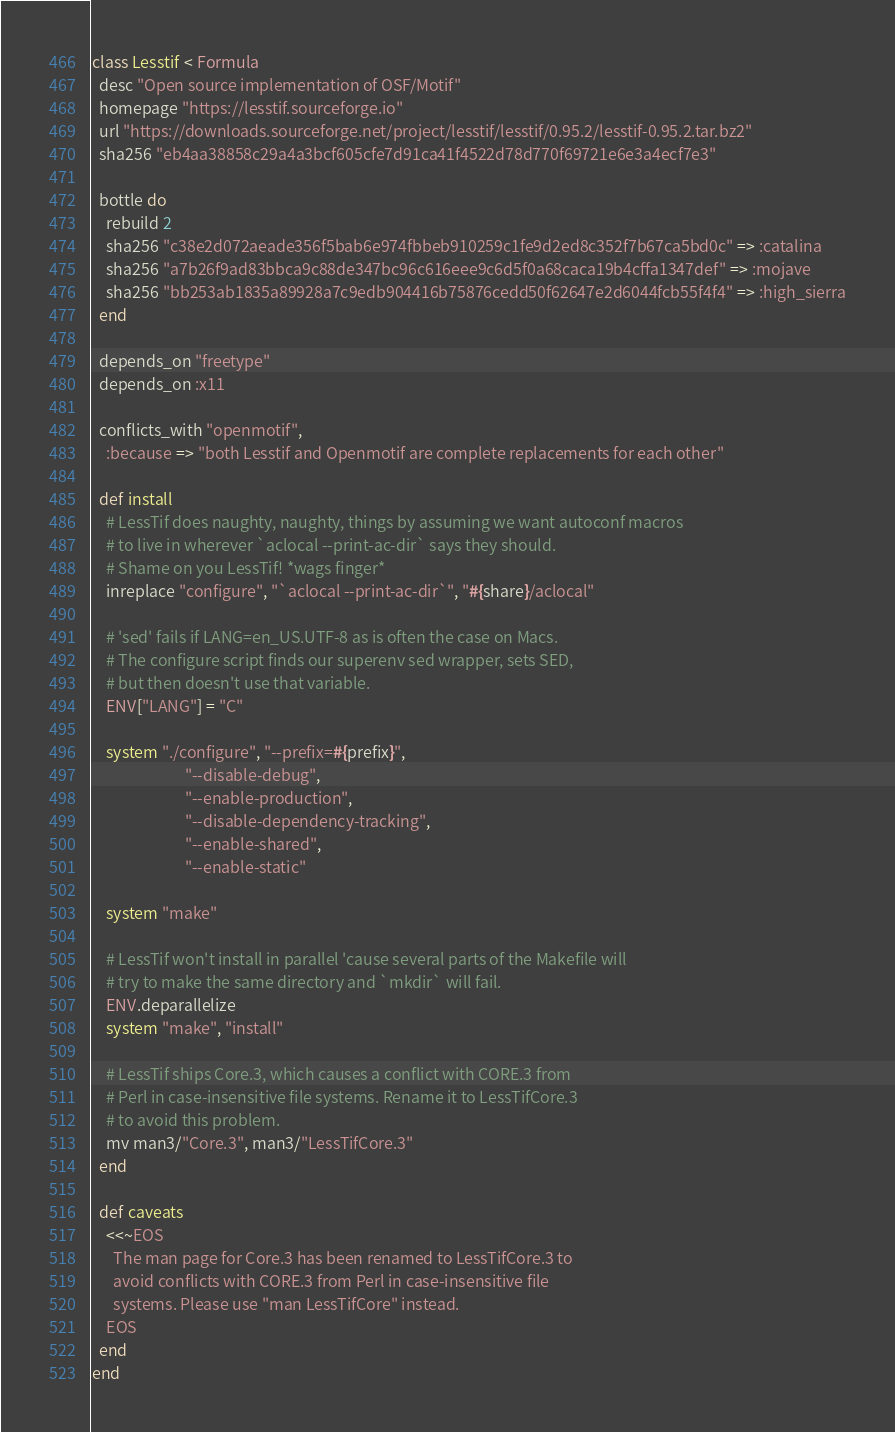Convert code to text. <code><loc_0><loc_0><loc_500><loc_500><_Ruby_>class Lesstif < Formula
  desc "Open source implementation of OSF/Motif"
  homepage "https://lesstif.sourceforge.io"
  url "https://downloads.sourceforge.net/project/lesstif/lesstif/0.95.2/lesstif-0.95.2.tar.bz2"
  sha256 "eb4aa38858c29a4a3bcf605cfe7d91ca41f4522d78d770f69721e6e3a4ecf7e3"

  bottle do
    rebuild 2
    sha256 "c38e2d072aeade356f5bab6e974fbbeb910259c1fe9d2ed8c352f7b67ca5bd0c" => :catalina
    sha256 "a7b26f9ad83bbca9c88de347bc96c616eee9c6d5f0a68caca19b4cffa1347def" => :mojave
    sha256 "bb253ab1835a89928a7c9edb904416b75876cedd50f62647e2d6044fcb55f4f4" => :high_sierra
  end

  depends_on "freetype"
  depends_on :x11

  conflicts_with "openmotif",
    :because => "both Lesstif and Openmotif are complete replacements for each other"

  def install
    # LessTif does naughty, naughty, things by assuming we want autoconf macros
    # to live in wherever `aclocal --print-ac-dir` says they should.
    # Shame on you LessTif! *wags finger*
    inreplace "configure", "`aclocal --print-ac-dir`", "#{share}/aclocal"

    # 'sed' fails if LANG=en_US.UTF-8 as is often the case on Macs.
    # The configure script finds our superenv sed wrapper, sets SED,
    # but then doesn't use that variable.
    ENV["LANG"] = "C"

    system "./configure", "--prefix=#{prefix}",
                          "--disable-debug",
                          "--enable-production",
                          "--disable-dependency-tracking",
                          "--enable-shared",
                          "--enable-static"

    system "make"

    # LessTif won't install in parallel 'cause several parts of the Makefile will
    # try to make the same directory and `mkdir` will fail.
    ENV.deparallelize
    system "make", "install"

    # LessTif ships Core.3, which causes a conflict with CORE.3 from
    # Perl in case-insensitive file systems. Rename it to LessTifCore.3
    # to avoid this problem.
    mv man3/"Core.3", man3/"LessTifCore.3"
  end

  def caveats
    <<~EOS
      The man page for Core.3 has been renamed to LessTifCore.3 to 
      avoid conflicts with CORE.3 from Perl in case-insensitive file 
      systems. Please use "man LessTifCore" instead.
    EOS
  end
end
</code> 